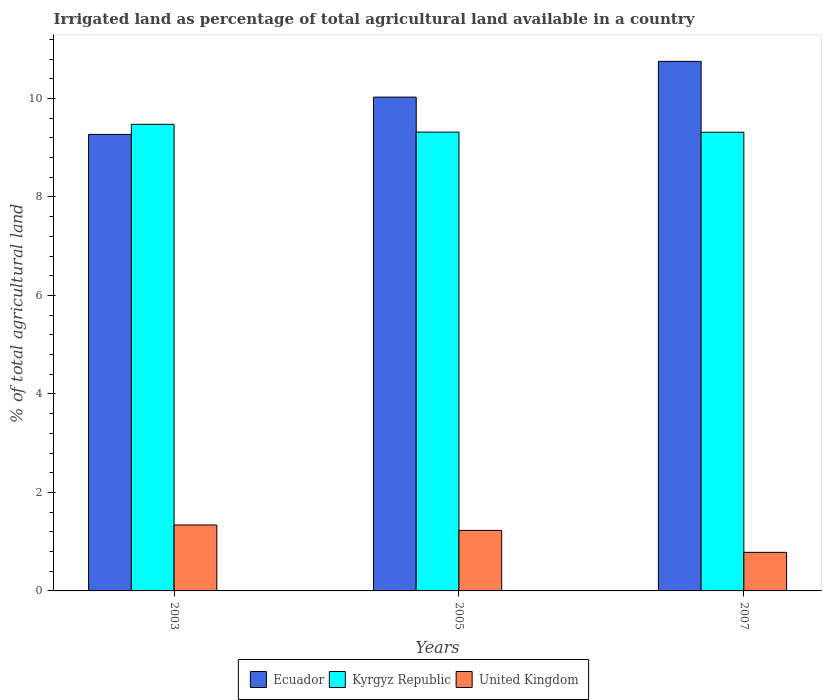How many groups of bars are there?
Ensure brevity in your answer.  3. Are the number of bars per tick equal to the number of legend labels?
Provide a succinct answer. Yes. How many bars are there on the 1st tick from the left?
Keep it short and to the point. 3. How many bars are there on the 2nd tick from the right?
Give a very brief answer. 3. What is the label of the 1st group of bars from the left?
Your response must be concise. 2003. What is the percentage of irrigated land in Kyrgyz Republic in 2005?
Offer a terse response. 9.32. Across all years, what is the maximum percentage of irrigated land in United Kingdom?
Give a very brief answer. 1.34. Across all years, what is the minimum percentage of irrigated land in United Kingdom?
Your answer should be compact. 0.78. In which year was the percentage of irrigated land in Kyrgyz Republic maximum?
Provide a succinct answer. 2003. In which year was the percentage of irrigated land in United Kingdom minimum?
Make the answer very short. 2007. What is the total percentage of irrigated land in Ecuador in the graph?
Offer a terse response. 30.05. What is the difference between the percentage of irrigated land in United Kingdom in 2003 and that in 2007?
Offer a very short reply. 0.56. What is the difference between the percentage of irrigated land in Ecuador in 2007 and the percentage of irrigated land in United Kingdom in 2005?
Your answer should be very brief. 9.52. What is the average percentage of irrigated land in Ecuador per year?
Ensure brevity in your answer.  10.02. In the year 2007, what is the difference between the percentage of irrigated land in Kyrgyz Republic and percentage of irrigated land in Ecuador?
Your response must be concise. -1.44. In how many years, is the percentage of irrigated land in United Kingdom greater than 6.8 %?
Your answer should be compact. 0. What is the ratio of the percentage of irrigated land in Kyrgyz Republic in 2003 to that in 2007?
Offer a terse response. 1.02. Is the difference between the percentage of irrigated land in Kyrgyz Republic in 2003 and 2005 greater than the difference between the percentage of irrigated land in Ecuador in 2003 and 2005?
Provide a succinct answer. Yes. What is the difference between the highest and the second highest percentage of irrigated land in United Kingdom?
Keep it short and to the point. 0.11. What is the difference between the highest and the lowest percentage of irrigated land in Ecuador?
Keep it short and to the point. 1.48. Is the sum of the percentage of irrigated land in Kyrgyz Republic in 2005 and 2007 greater than the maximum percentage of irrigated land in Ecuador across all years?
Give a very brief answer. Yes. What does the 1st bar from the left in 2007 represents?
Provide a succinct answer. Ecuador. What does the 3rd bar from the right in 2005 represents?
Provide a succinct answer. Ecuador. How many bars are there?
Offer a very short reply. 9. What is the difference between two consecutive major ticks on the Y-axis?
Your response must be concise. 2. Does the graph contain grids?
Offer a terse response. No. Where does the legend appear in the graph?
Your response must be concise. Bottom center. What is the title of the graph?
Provide a succinct answer. Irrigated land as percentage of total agricultural land available in a country. Does "Cyprus" appear as one of the legend labels in the graph?
Ensure brevity in your answer.  No. What is the label or title of the Y-axis?
Your answer should be very brief. % of total agricultural land. What is the % of total agricultural land in Ecuador in 2003?
Offer a very short reply. 9.27. What is the % of total agricultural land in Kyrgyz Republic in 2003?
Ensure brevity in your answer.  9.47. What is the % of total agricultural land in United Kingdom in 2003?
Give a very brief answer. 1.34. What is the % of total agricultural land in Ecuador in 2005?
Provide a succinct answer. 10.03. What is the % of total agricultural land in Kyrgyz Republic in 2005?
Make the answer very short. 9.32. What is the % of total agricultural land of United Kingdom in 2005?
Your answer should be very brief. 1.23. What is the % of total agricultural land of Ecuador in 2007?
Ensure brevity in your answer.  10.75. What is the % of total agricultural land in Kyrgyz Republic in 2007?
Offer a very short reply. 9.31. What is the % of total agricultural land of United Kingdom in 2007?
Provide a succinct answer. 0.78. Across all years, what is the maximum % of total agricultural land in Ecuador?
Offer a terse response. 10.75. Across all years, what is the maximum % of total agricultural land of Kyrgyz Republic?
Make the answer very short. 9.47. Across all years, what is the maximum % of total agricultural land in United Kingdom?
Your response must be concise. 1.34. Across all years, what is the minimum % of total agricultural land in Ecuador?
Give a very brief answer. 9.27. Across all years, what is the minimum % of total agricultural land in Kyrgyz Republic?
Keep it short and to the point. 9.31. Across all years, what is the minimum % of total agricultural land in United Kingdom?
Give a very brief answer. 0.78. What is the total % of total agricultural land of Ecuador in the graph?
Ensure brevity in your answer.  30.05. What is the total % of total agricultural land of Kyrgyz Republic in the graph?
Your answer should be compact. 28.1. What is the total % of total agricultural land of United Kingdom in the graph?
Ensure brevity in your answer.  3.35. What is the difference between the % of total agricultural land in Ecuador in 2003 and that in 2005?
Your answer should be very brief. -0.76. What is the difference between the % of total agricultural land in Kyrgyz Republic in 2003 and that in 2005?
Offer a very short reply. 0.16. What is the difference between the % of total agricultural land of United Kingdom in 2003 and that in 2005?
Your answer should be very brief. 0.11. What is the difference between the % of total agricultural land of Ecuador in 2003 and that in 2007?
Ensure brevity in your answer.  -1.48. What is the difference between the % of total agricultural land of Kyrgyz Republic in 2003 and that in 2007?
Keep it short and to the point. 0.16. What is the difference between the % of total agricultural land of United Kingdom in 2003 and that in 2007?
Your response must be concise. 0.56. What is the difference between the % of total agricultural land in Ecuador in 2005 and that in 2007?
Make the answer very short. -0.73. What is the difference between the % of total agricultural land of Kyrgyz Republic in 2005 and that in 2007?
Your response must be concise. 0. What is the difference between the % of total agricultural land in United Kingdom in 2005 and that in 2007?
Provide a succinct answer. 0.45. What is the difference between the % of total agricultural land of Ecuador in 2003 and the % of total agricultural land of Kyrgyz Republic in 2005?
Keep it short and to the point. -0.05. What is the difference between the % of total agricultural land of Ecuador in 2003 and the % of total agricultural land of United Kingdom in 2005?
Provide a short and direct response. 8.04. What is the difference between the % of total agricultural land of Kyrgyz Republic in 2003 and the % of total agricultural land of United Kingdom in 2005?
Provide a short and direct response. 8.25. What is the difference between the % of total agricultural land of Ecuador in 2003 and the % of total agricultural land of Kyrgyz Republic in 2007?
Make the answer very short. -0.04. What is the difference between the % of total agricultural land of Ecuador in 2003 and the % of total agricultural land of United Kingdom in 2007?
Offer a terse response. 8.49. What is the difference between the % of total agricultural land of Kyrgyz Republic in 2003 and the % of total agricultural land of United Kingdom in 2007?
Offer a very short reply. 8.69. What is the difference between the % of total agricultural land in Ecuador in 2005 and the % of total agricultural land in Kyrgyz Republic in 2007?
Make the answer very short. 0.71. What is the difference between the % of total agricultural land in Ecuador in 2005 and the % of total agricultural land in United Kingdom in 2007?
Ensure brevity in your answer.  9.24. What is the difference between the % of total agricultural land in Kyrgyz Republic in 2005 and the % of total agricultural land in United Kingdom in 2007?
Your answer should be compact. 8.53. What is the average % of total agricultural land of Ecuador per year?
Provide a succinct answer. 10.02. What is the average % of total agricultural land of Kyrgyz Republic per year?
Offer a terse response. 9.37. What is the average % of total agricultural land in United Kingdom per year?
Your answer should be very brief. 1.12. In the year 2003, what is the difference between the % of total agricultural land of Ecuador and % of total agricultural land of Kyrgyz Republic?
Your response must be concise. -0.21. In the year 2003, what is the difference between the % of total agricultural land of Ecuador and % of total agricultural land of United Kingdom?
Keep it short and to the point. 7.93. In the year 2003, what is the difference between the % of total agricultural land of Kyrgyz Republic and % of total agricultural land of United Kingdom?
Your response must be concise. 8.13. In the year 2005, what is the difference between the % of total agricultural land of Ecuador and % of total agricultural land of Kyrgyz Republic?
Give a very brief answer. 0.71. In the year 2005, what is the difference between the % of total agricultural land of Ecuador and % of total agricultural land of United Kingdom?
Give a very brief answer. 8.8. In the year 2005, what is the difference between the % of total agricultural land of Kyrgyz Republic and % of total agricultural land of United Kingdom?
Keep it short and to the point. 8.09. In the year 2007, what is the difference between the % of total agricultural land in Ecuador and % of total agricultural land in Kyrgyz Republic?
Your answer should be very brief. 1.44. In the year 2007, what is the difference between the % of total agricultural land of Ecuador and % of total agricultural land of United Kingdom?
Offer a terse response. 9.97. In the year 2007, what is the difference between the % of total agricultural land of Kyrgyz Republic and % of total agricultural land of United Kingdom?
Provide a succinct answer. 8.53. What is the ratio of the % of total agricultural land of Ecuador in 2003 to that in 2005?
Provide a short and direct response. 0.92. What is the ratio of the % of total agricultural land in United Kingdom in 2003 to that in 2005?
Give a very brief answer. 1.09. What is the ratio of the % of total agricultural land in Ecuador in 2003 to that in 2007?
Your answer should be compact. 0.86. What is the ratio of the % of total agricultural land of Kyrgyz Republic in 2003 to that in 2007?
Ensure brevity in your answer.  1.02. What is the ratio of the % of total agricultural land in United Kingdom in 2003 to that in 2007?
Offer a very short reply. 1.71. What is the ratio of the % of total agricultural land of Ecuador in 2005 to that in 2007?
Give a very brief answer. 0.93. What is the ratio of the % of total agricultural land in Kyrgyz Republic in 2005 to that in 2007?
Your answer should be compact. 1. What is the ratio of the % of total agricultural land in United Kingdom in 2005 to that in 2007?
Make the answer very short. 1.57. What is the difference between the highest and the second highest % of total agricultural land in Ecuador?
Your answer should be very brief. 0.73. What is the difference between the highest and the second highest % of total agricultural land of Kyrgyz Republic?
Make the answer very short. 0.16. What is the difference between the highest and the second highest % of total agricultural land of United Kingdom?
Offer a very short reply. 0.11. What is the difference between the highest and the lowest % of total agricultural land of Ecuador?
Your response must be concise. 1.48. What is the difference between the highest and the lowest % of total agricultural land in Kyrgyz Republic?
Your answer should be very brief. 0.16. What is the difference between the highest and the lowest % of total agricultural land of United Kingdom?
Your answer should be compact. 0.56. 